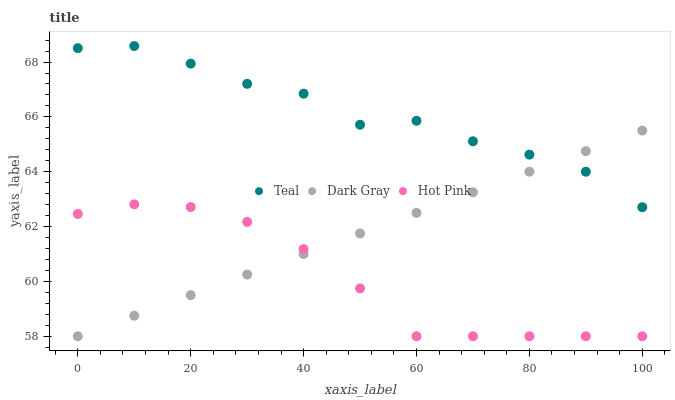Does Hot Pink have the minimum area under the curve?
Answer yes or no. Yes. Does Teal have the maximum area under the curve?
Answer yes or no. Yes. Does Teal have the minimum area under the curve?
Answer yes or no. No. Does Hot Pink have the maximum area under the curve?
Answer yes or no. No. Is Dark Gray the smoothest?
Answer yes or no. Yes. Is Teal the roughest?
Answer yes or no. Yes. Is Hot Pink the smoothest?
Answer yes or no. No. Is Hot Pink the roughest?
Answer yes or no. No. Does Dark Gray have the lowest value?
Answer yes or no. Yes. Does Teal have the lowest value?
Answer yes or no. No. Does Teal have the highest value?
Answer yes or no. Yes. Does Hot Pink have the highest value?
Answer yes or no. No. Is Hot Pink less than Teal?
Answer yes or no. Yes. Is Teal greater than Hot Pink?
Answer yes or no. Yes. Does Teal intersect Dark Gray?
Answer yes or no. Yes. Is Teal less than Dark Gray?
Answer yes or no. No. Is Teal greater than Dark Gray?
Answer yes or no. No. Does Hot Pink intersect Teal?
Answer yes or no. No. 